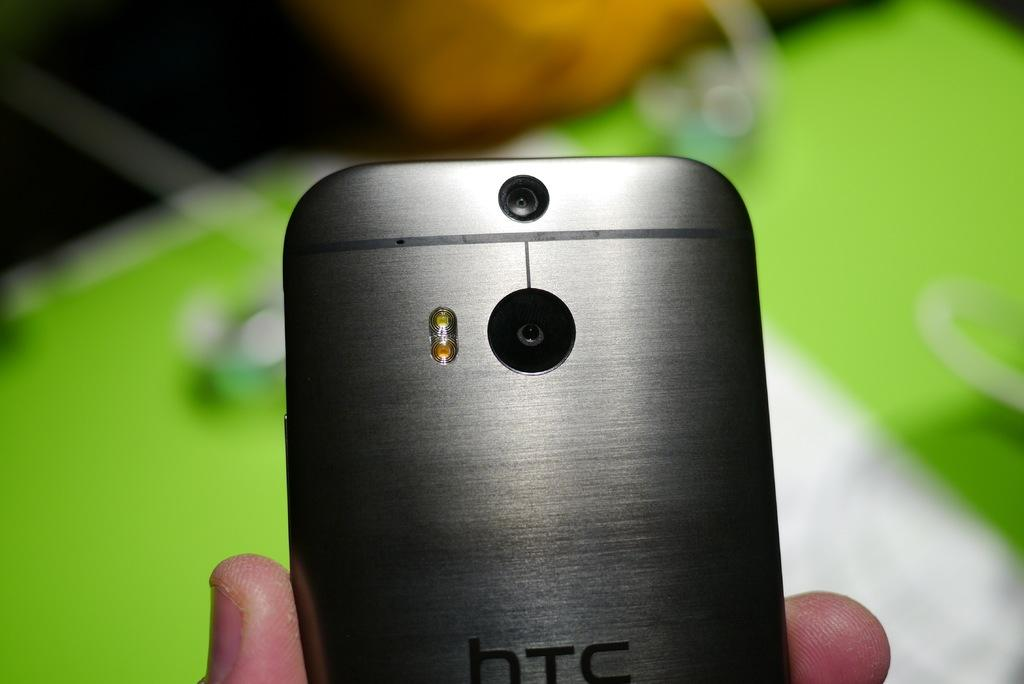What can be seen in the image? There is a human hand in the image. What is the hand holding? The hand is holding a mobile phone. What type of locket can be seen hanging from the banana at the seashore in the image? There is no locket, banana, or seashore present in the image; it only features a human hand holding a mobile phone. 